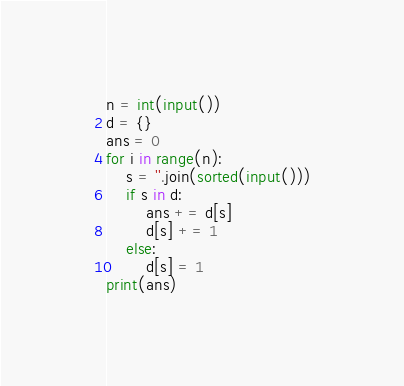<code> <loc_0><loc_0><loc_500><loc_500><_Python_>n = int(input())
d = {}
ans = 0
for i in range(n):
    s = ''.join(sorted(input()))
    if s in d:
        ans += d[s]
        d[s] += 1
    else:
        d[s] = 1
print(ans)</code> 